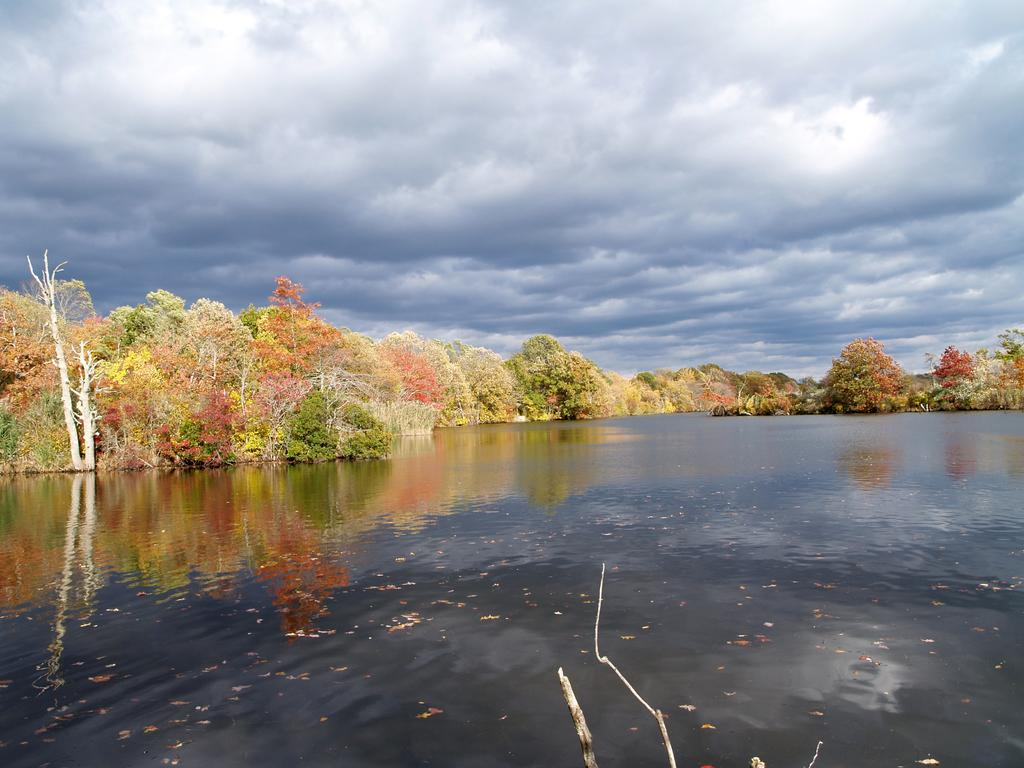What type of vegetation can be seen in the image? There are trees in the image. What natural element is visible in the image besides the trees? There is water visible in the image. How would you describe the sky in the image? The sky is blue and cloudy in the image. How many mice can be seen running on the floor in the image? There are no mice or floors present in the image; it features trees, water, and a blue, cloudy sky. 